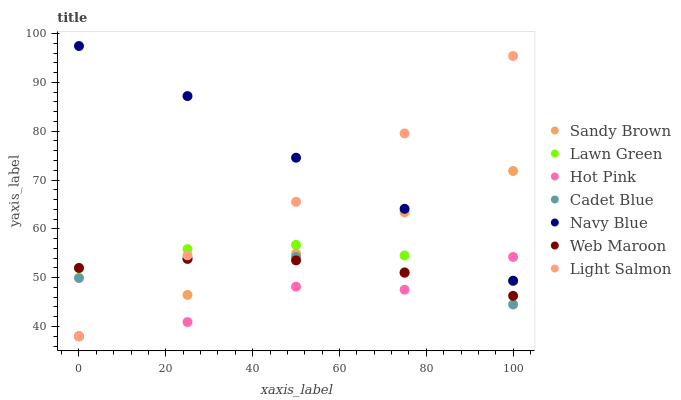Does Hot Pink have the minimum area under the curve?
Answer yes or no. Yes. Does Navy Blue have the maximum area under the curve?
Answer yes or no. Yes. Does Light Salmon have the minimum area under the curve?
Answer yes or no. No. Does Light Salmon have the maximum area under the curve?
Answer yes or no. No. Is Sandy Brown the smoothest?
Answer yes or no. Yes. Is Hot Pink the roughest?
Answer yes or no. Yes. Is Light Salmon the smoothest?
Answer yes or no. No. Is Light Salmon the roughest?
Answer yes or no. No. Does Light Salmon have the lowest value?
Answer yes or no. Yes. Does Cadet Blue have the lowest value?
Answer yes or no. No. Does Navy Blue have the highest value?
Answer yes or no. Yes. Does Light Salmon have the highest value?
Answer yes or no. No. Is Web Maroon less than Navy Blue?
Answer yes or no. Yes. Is Navy Blue greater than Web Maroon?
Answer yes or no. Yes. Does Navy Blue intersect Hot Pink?
Answer yes or no. Yes. Is Navy Blue less than Hot Pink?
Answer yes or no. No. Is Navy Blue greater than Hot Pink?
Answer yes or no. No. Does Web Maroon intersect Navy Blue?
Answer yes or no. No. 